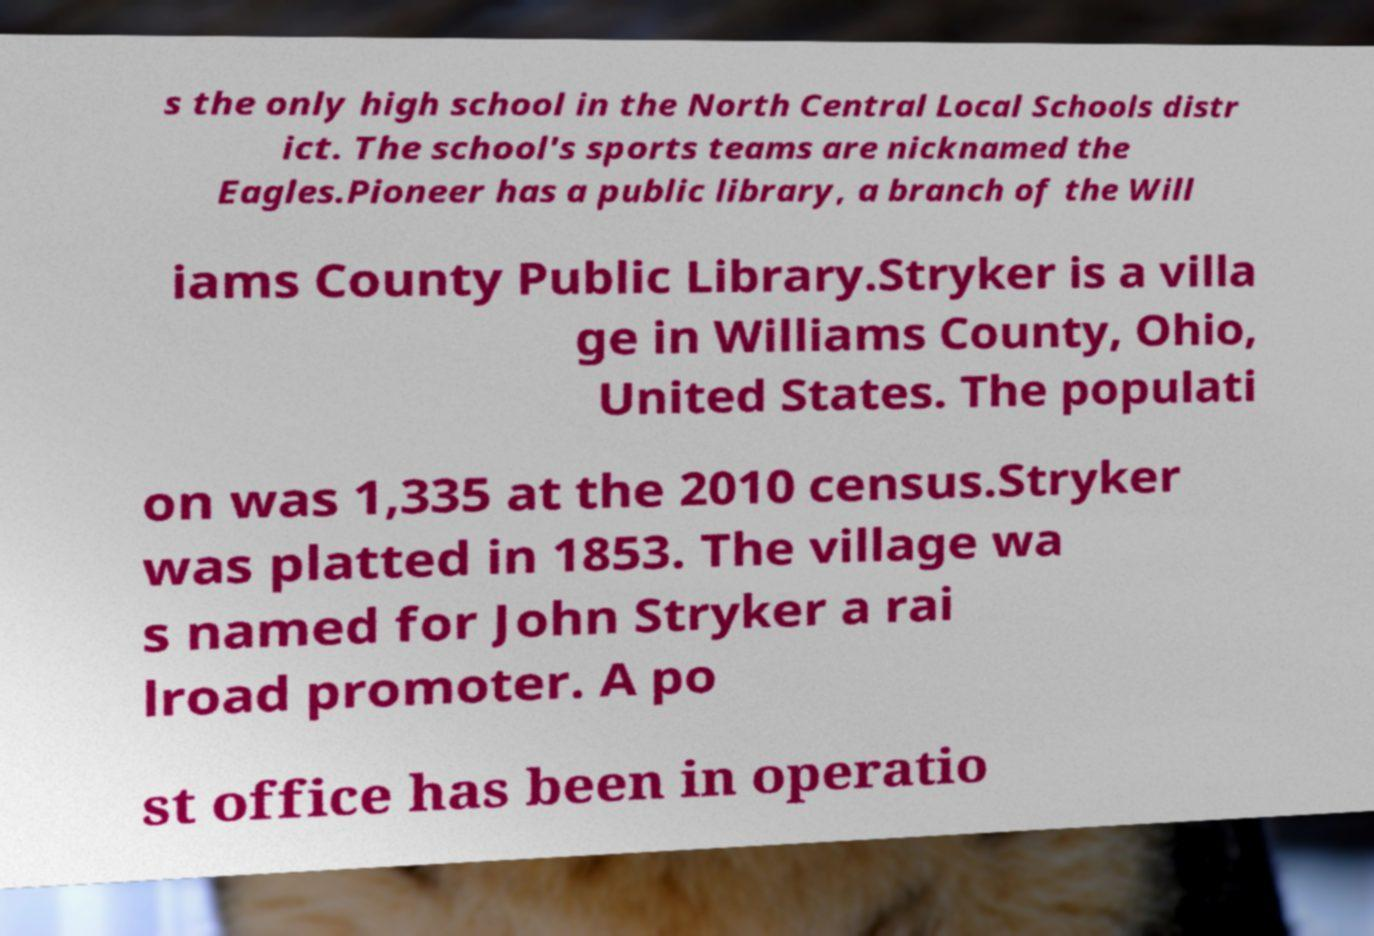Please read and relay the text visible in this image. What does it say? s the only high school in the North Central Local Schools distr ict. The school's sports teams are nicknamed the Eagles.Pioneer has a public library, a branch of the Will iams County Public Library.Stryker is a villa ge in Williams County, Ohio, United States. The populati on was 1,335 at the 2010 census.Stryker was platted in 1853. The village wa s named for John Stryker a rai lroad promoter. A po st office has been in operatio 